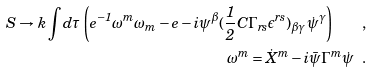<formula> <loc_0><loc_0><loc_500><loc_500>S \rightarrow k \int d \tau \left ( e ^ { - 1 } \omega ^ { m } \omega _ { m } - e - i \psi ^ { \beta } ( \frac { 1 } { 2 } C \Gamma _ { r s } \epsilon ^ { r s } ) _ { \beta \gamma } \dot { \psi } ^ { \gamma } \right ) \quad , \\ \omega ^ { m } = \dot { X } ^ { m } - i \bar { \psi } \Gamma ^ { m } \dot { \psi } \ \ .</formula> 